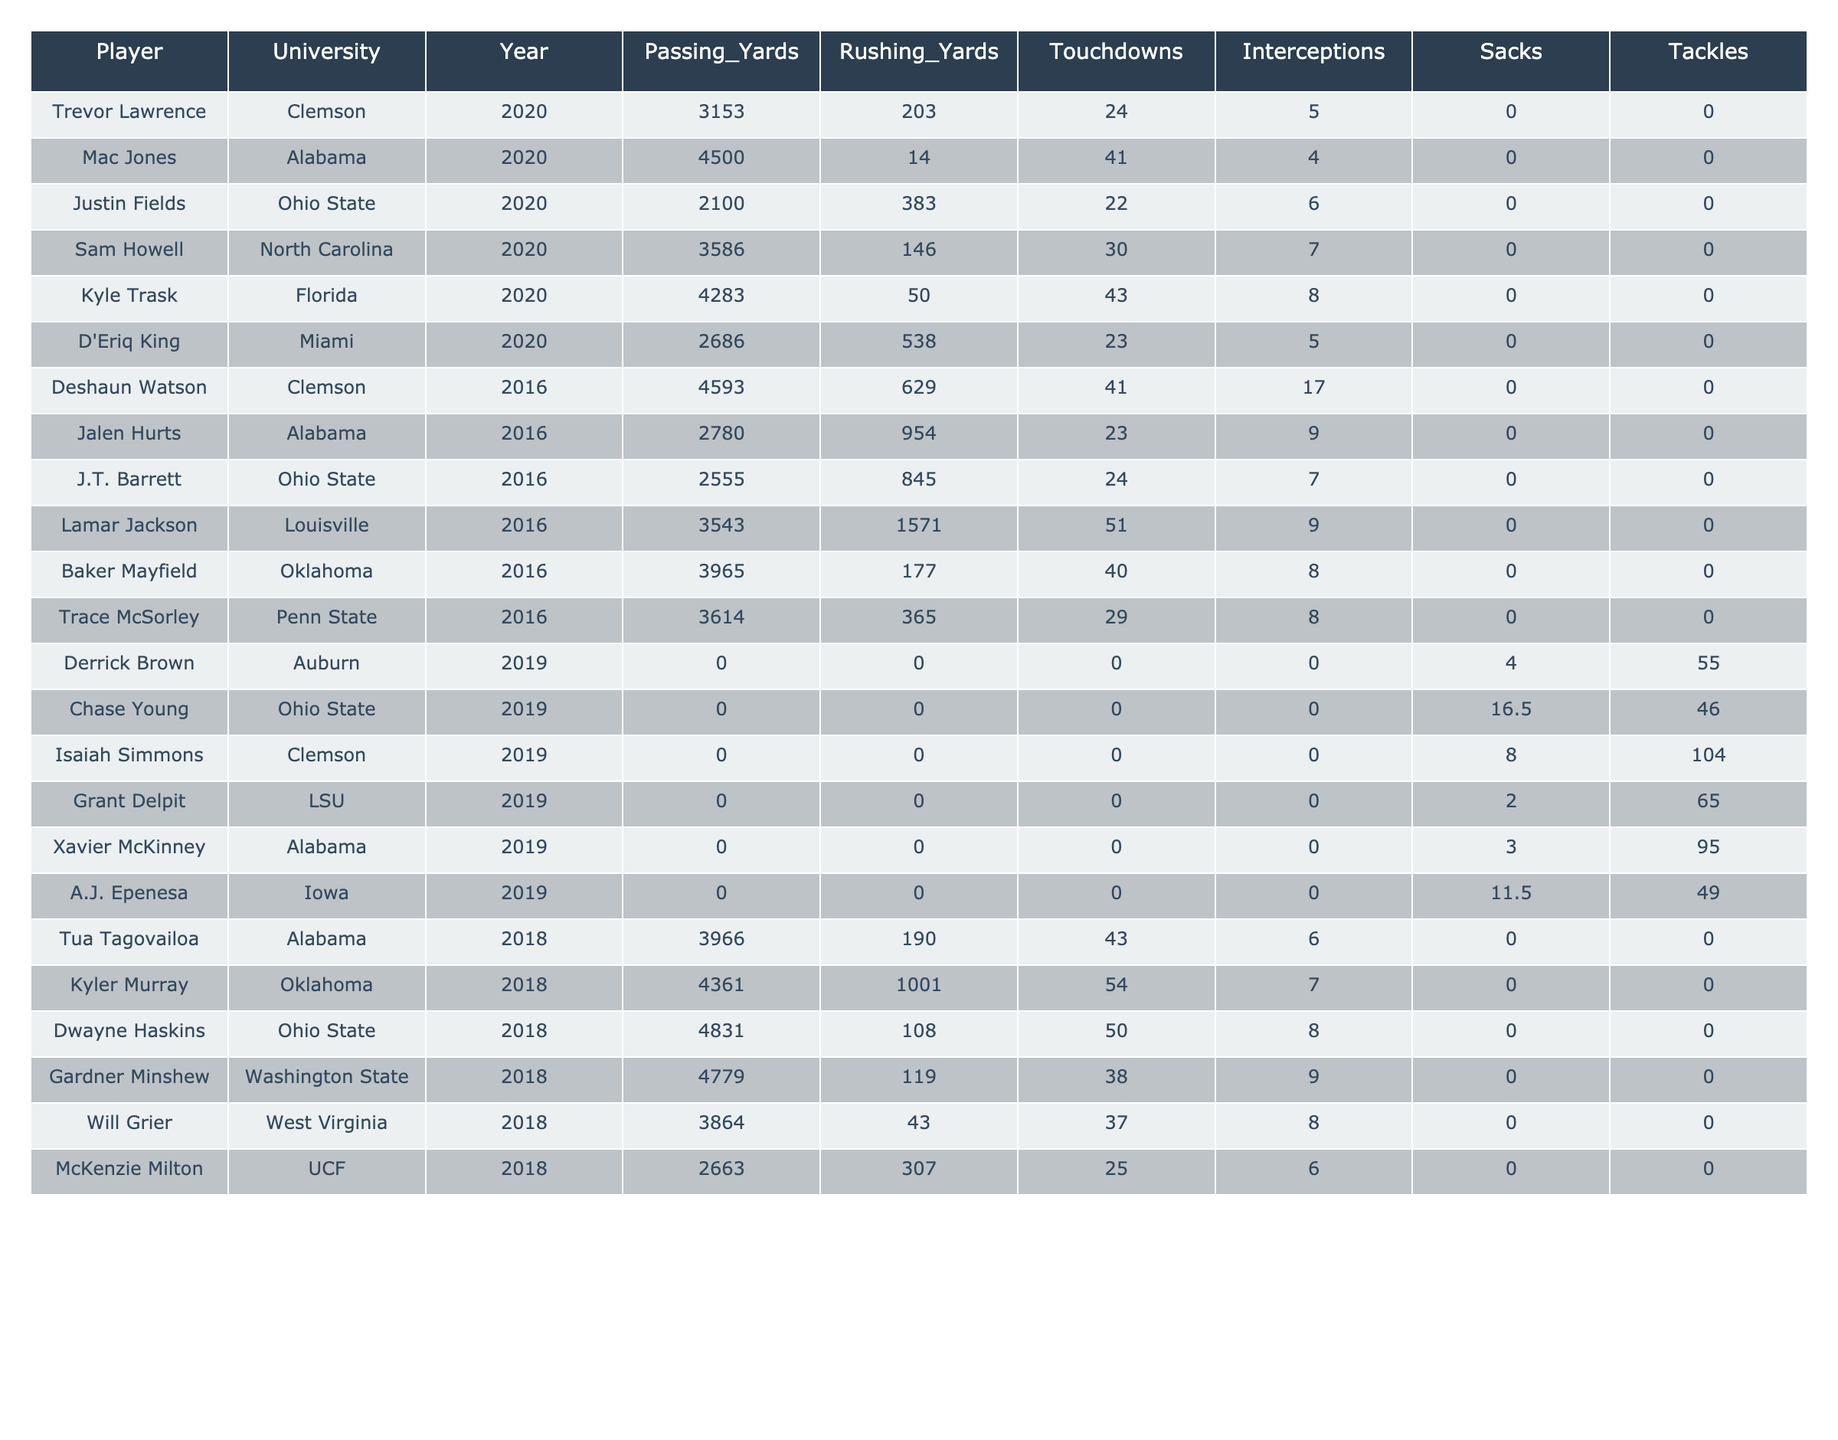What was the highest number of passing yards recorded in a single year? The maximum value in the Passing Yards column is 4831, recorded by Dwayne Haskins from Ohio State in 2018.
Answer: 4831 Which player scored the most touchdowns? The highest value in the Touchdowns column is 54, achieved by Kyler Murray from Oklahoma in 2018.
Answer: 54 How many players had zero passing yards? There are five players listed with zero passing yards, indicated as 0 in the Passing Yards column for their respective years.
Answer: 5 What is the total number of touchdowns scored by players from Alabama? Adding the touchdowns for the Alabama players: 41 (Mac Jones, 2020) + 23 (Jalen Hurts, 2016) + 43 (Tua Tagovailoa, 2018) = 107 touchdowns.
Answer: 107 Did any player from Ohio State have more rushing yards than Justin Fields in 2020? Justin Fields recorded 383 rushing yards in 2020, and no other player from Ohio State in the data exceeded this value in that year.
Answer: No What is the average number of interceptions across all players? Summing the interceptions: 5 (Trevor Lawrence) + 4 (Mac Jones) + 6 (Justin Fields) + 7 (Sam Howell) + 8 (Kyle Trask) + 5 (D'Eriq King) + 17 (Deshaun Watson) + 9 (Jalen Hurts) + 7 (J.T. Barrett) + 9 (Lamar Jackson) + 8 (Baker Mayfield) + 8 (Trace McSorley) + 0 + 0 + 0 + 0 + 0 + 0 + 6 (Tua Tagovailoa) + 7 (Kyler Murray) + 8 (Dwayne Haskins) + 9 (Gardner Minshew) + 8 (Will Grier) + 6 (McKenzie Milton) = 166 total interceptions over 21 players, resulting in an average of 166/21 ≈ 7.90.
Answer: 7.90 Which university had the player with the most rushing yards in the provided data? The highest rushing yards recorded were by Lamar Jackson from Louisville with 1571 rushing yards in 2016. Therefore, no player from the universities in the rivalry had more.
Answer: Louisville Who had the best sack total among the players mentioned? The player with the highest sacks is Chase Young from Ohio State with 16.5 sacks in 2019.
Answer: 16.5 What proportion of players had more touchdowns than interceptions? Out of 21 players, 13 had more touchdowns than interceptions, resulting in a proportion of 13/21 ≈ 0.62.
Answer: 0.62 What is the highest number of rushing yards recorded by a player from Clemson? The highest rushing yards recorded by a Clemson player is 629, achieved by Deshaun Watson in 2016.
Answer: 629 In which year did Ohio State's Dwayne Haskins play, and how many passing yards did he throw? Dwayne Haskins played in 2018 and recorded 4831 passing yards.
Answer: 2018, 4831 